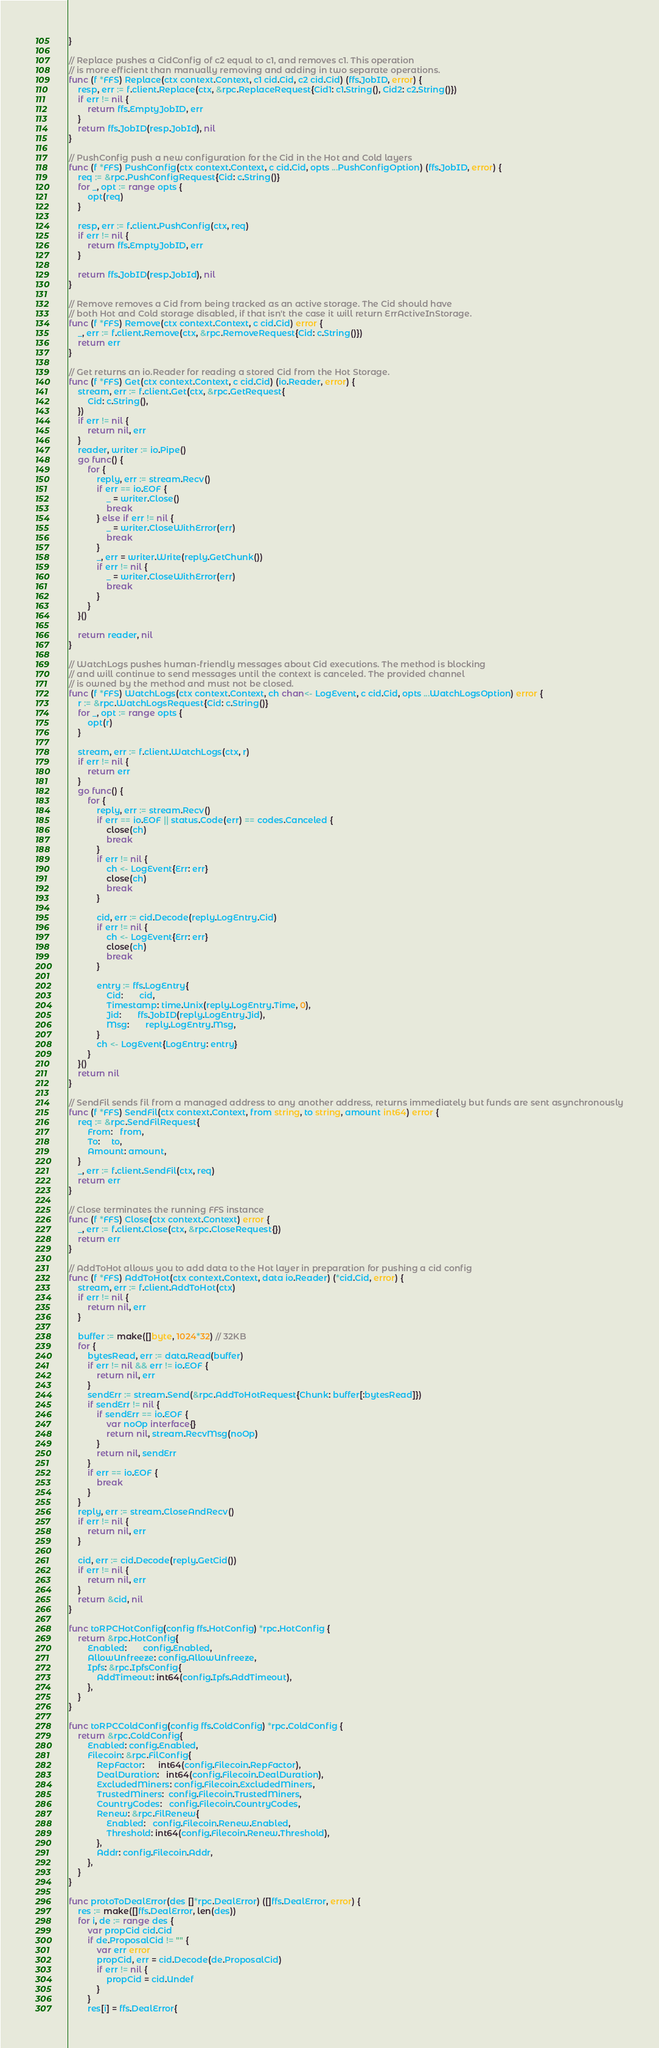Convert code to text. <code><loc_0><loc_0><loc_500><loc_500><_Go_>}

// Replace pushes a CidConfig of c2 equal to c1, and removes c1. This operation
// is more efficient than manually removing and adding in two separate operations.
func (f *FFS) Replace(ctx context.Context, c1 cid.Cid, c2 cid.Cid) (ffs.JobID, error) {
	resp, err := f.client.Replace(ctx, &rpc.ReplaceRequest{Cid1: c1.String(), Cid2: c2.String()})
	if err != nil {
		return ffs.EmptyJobID, err
	}
	return ffs.JobID(resp.JobId), nil
}

// PushConfig push a new configuration for the Cid in the Hot and Cold layers
func (f *FFS) PushConfig(ctx context.Context, c cid.Cid, opts ...PushConfigOption) (ffs.JobID, error) {
	req := &rpc.PushConfigRequest{Cid: c.String()}
	for _, opt := range opts {
		opt(req)
	}

	resp, err := f.client.PushConfig(ctx, req)
	if err != nil {
		return ffs.EmptyJobID, err
	}

	return ffs.JobID(resp.JobId), nil
}

// Remove removes a Cid from being tracked as an active storage. The Cid should have
// both Hot and Cold storage disabled, if that isn't the case it will return ErrActiveInStorage.
func (f *FFS) Remove(ctx context.Context, c cid.Cid) error {
	_, err := f.client.Remove(ctx, &rpc.RemoveRequest{Cid: c.String()})
	return err
}

// Get returns an io.Reader for reading a stored Cid from the Hot Storage.
func (f *FFS) Get(ctx context.Context, c cid.Cid) (io.Reader, error) {
	stream, err := f.client.Get(ctx, &rpc.GetRequest{
		Cid: c.String(),
	})
	if err != nil {
		return nil, err
	}
	reader, writer := io.Pipe()
	go func() {
		for {
			reply, err := stream.Recv()
			if err == io.EOF {
				_ = writer.Close()
				break
			} else if err != nil {
				_ = writer.CloseWithError(err)
				break
			}
			_, err = writer.Write(reply.GetChunk())
			if err != nil {
				_ = writer.CloseWithError(err)
				break
			}
		}
	}()

	return reader, nil
}

// WatchLogs pushes human-friendly messages about Cid executions. The method is blocking
// and will continue to send messages until the context is canceled. The provided channel
// is owned by the method and must not be closed.
func (f *FFS) WatchLogs(ctx context.Context, ch chan<- LogEvent, c cid.Cid, opts ...WatchLogsOption) error {
	r := &rpc.WatchLogsRequest{Cid: c.String()}
	for _, opt := range opts {
		opt(r)
	}

	stream, err := f.client.WatchLogs(ctx, r)
	if err != nil {
		return err
	}
	go func() {
		for {
			reply, err := stream.Recv()
			if err == io.EOF || status.Code(err) == codes.Canceled {
				close(ch)
				break
			}
			if err != nil {
				ch <- LogEvent{Err: err}
				close(ch)
				break
			}

			cid, err := cid.Decode(reply.LogEntry.Cid)
			if err != nil {
				ch <- LogEvent{Err: err}
				close(ch)
				break
			}

			entry := ffs.LogEntry{
				Cid:       cid,
				Timestamp: time.Unix(reply.LogEntry.Time, 0),
				Jid:       ffs.JobID(reply.LogEntry.Jid),
				Msg:       reply.LogEntry.Msg,
			}
			ch <- LogEvent{LogEntry: entry}
		}
	}()
	return nil
}

// SendFil sends fil from a managed address to any another address, returns immediately but funds are sent asynchronously
func (f *FFS) SendFil(ctx context.Context, from string, to string, amount int64) error {
	req := &rpc.SendFilRequest{
		From:   from,
		To:     to,
		Amount: amount,
	}
	_, err := f.client.SendFil(ctx, req)
	return err
}

// Close terminates the running FFS instance
func (f *FFS) Close(ctx context.Context) error {
	_, err := f.client.Close(ctx, &rpc.CloseRequest{})
	return err
}

// AddToHot allows you to add data to the Hot layer in preparation for pushing a cid config
func (f *FFS) AddToHot(ctx context.Context, data io.Reader) (*cid.Cid, error) {
	stream, err := f.client.AddToHot(ctx)
	if err != nil {
		return nil, err
	}

	buffer := make([]byte, 1024*32) // 32KB
	for {
		bytesRead, err := data.Read(buffer)
		if err != nil && err != io.EOF {
			return nil, err
		}
		sendErr := stream.Send(&rpc.AddToHotRequest{Chunk: buffer[:bytesRead]})
		if sendErr != nil {
			if sendErr == io.EOF {
				var noOp interface{}
				return nil, stream.RecvMsg(noOp)
			}
			return nil, sendErr
		}
		if err == io.EOF {
			break
		}
	}
	reply, err := stream.CloseAndRecv()
	if err != nil {
		return nil, err
	}

	cid, err := cid.Decode(reply.GetCid())
	if err != nil {
		return nil, err
	}
	return &cid, nil
}

func toRPCHotConfig(config ffs.HotConfig) *rpc.HotConfig {
	return &rpc.HotConfig{
		Enabled:       config.Enabled,
		AllowUnfreeze: config.AllowUnfreeze,
		Ipfs: &rpc.IpfsConfig{
			AddTimeout: int64(config.Ipfs.AddTimeout),
		},
	}
}

func toRPCColdConfig(config ffs.ColdConfig) *rpc.ColdConfig {
	return &rpc.ColdConfig{
		Enabled: config.Enabled,
		Filecoin: &rpc.FilConfig{
			RepFactor:      int64(config.Filecoin.RepFactor),
			DealDuration:   int64(config.Filecoin.DealDuration),
			ExcludedMiners: config.Filecoin.ExcludedMiners,
			TrustedMiners:  config.Filecoin.TrustedMiners,
			CountryCodes:   config.Filecoin.CountryCodes,
			Renew: &rpc.FilRenew{
				Enabled:   config.Filecoin.Renew.Enabled,
				Threshold: int64(config.Filecoin.Renew.Threshold),
			},
			Addr: config.Filecoin.Addr,
		},
	}
}

func protoToDealError(des []*rpc.DealError) ([]ffs.DealError, error) {
	res := make([]ffs.DealError, len(des))
	for i, de := range des {
		var propCid cid.Cid
		if de.ProposalCid != "" {
			var err error
			propCid, err = cid.Decode(de.ProposalCid)
			if err != nil {
				propCid = cid.Undef
			}
		}
		res[i] = ffs.DealError{</code> 